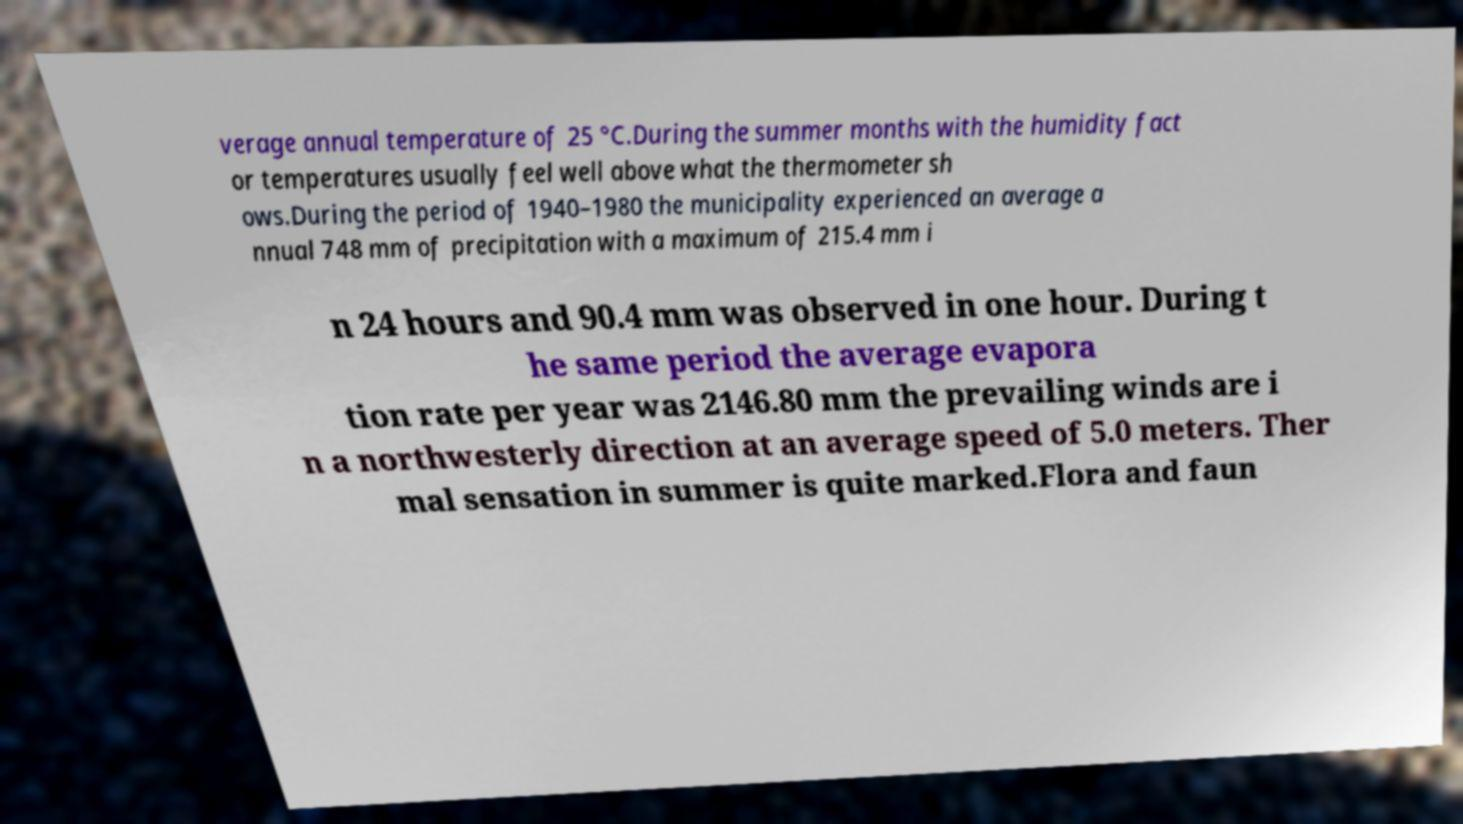There's text embedded in this image that I need extracted. Can you transcribe it verbatim? verage annual temperature of 25 °C.During the summer months with the humidity fact or temperatures usually feel well above what the thermometer sh ows.During the period of 1940–1980 the municipality experienced an average a nnual 748 mm of precipitation with a maximum of 215.4 mm i n 24 hours and 90.4 mm was observed in one hour. During t he same period the average evapora tion rate per year was 2146.80 mm the prevailing winds are i n a northwesterly direction at an average speed of 5.0 meters. Ther mal sensation in summer is quite marked.Flora and faun 